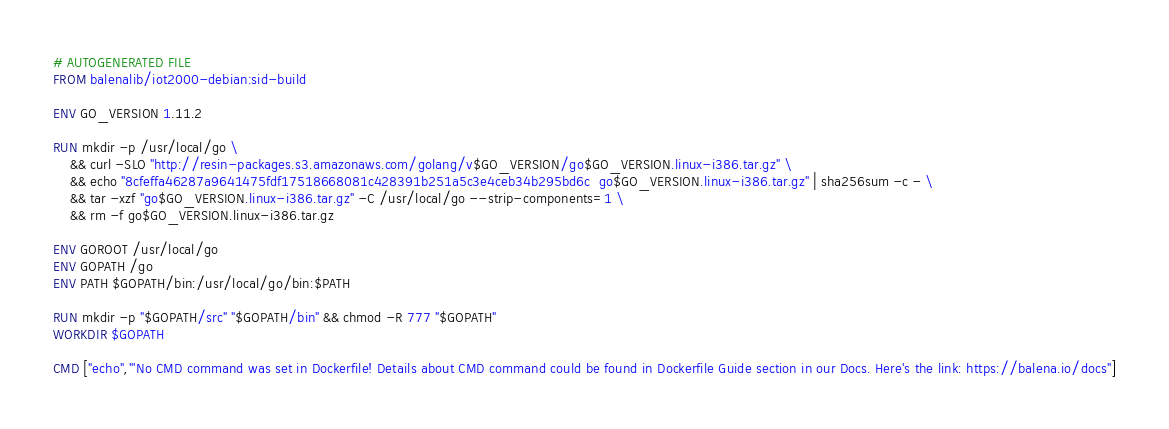Convert code to text. <code><loc_0><loc_0><loc_500><loc_500><_Dockerfile_># AUTOGENERATED FILE
FROM balenalib/iot2000-debian:sid-build

ENV GO_VERSION 1.11.2

RUN mkdir -p /usr/local/go \
	&& curl -SLO "http://resin-packages.s3.amazonaws.com/golang/v$GO_VERSION/go$GO_VERSION.linux-i386.tar.gz" \
	&& echo "8cfeffa46287a9641475fdf17518668081c428391b251a5c3e4ceb34b295bd6c  go$GO_VERSION.linux-i386.tar.gz" | sha256sum -c - \
	&& tar -xzf "go$GO_VERSION.linux-i386.tar.gz" -C /usr/local/go --strip-components=1 \
	&& rm -f go$GO_VERSION.linux-i386.tar.gz

ENV GOROOT /usr/local/go
ENV GOPATH /go
ENV PATH $GOPATH/bin:/usr/local/go/bin:$PATH

RUN mkdir -p "$GOPATH/src" "$GOPATH/bin" && chmod -R 777 "$GOPATH"
WORKDIR $GOPATH

CMD ["echo","'No CMD command was set in Dockerfile! Details about CMD command could be found in Dockerfile Guide section in our Docs. Here's the link: https://balena.io/docs"]</code> 